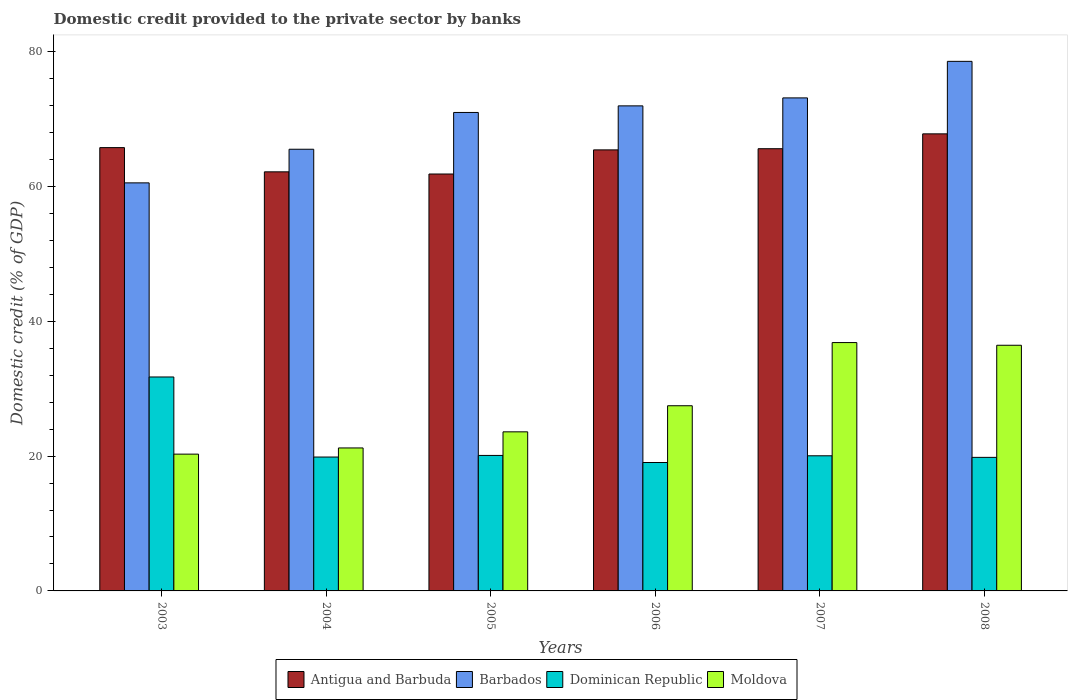How many different coloured bars are there?
Your response must be concise. 4. Are the number of bars per tick equal to the number of legend labels?
Provide a short and direct response. Yes. How many bars are there on the 4th tick from the left?
Keep it short and to the point. 4. In how many cases, is the number of bars for a given year not equal to the number of legend labels?
Give a very brief answer. 0. What is the domestic credit provided to the private sector by banks in Dominican Republic in 2007?
Your response must be concise. 20.05. Across all years, what is the maximum domestic credit provided to the private sector by banks in Antigua and Barbuda?
Offer a terse response. 67.81. Across all years, what is the minimum domestic credit provided to the private sector by banks in Dominican Republic?
Offer a terse response. 19.05. In which year was the domestic credit provided to the private sector by banks in Dominican Republic maximum?
Your answer should be compact. 2003. What is the total domestic credit provided to the private sector by banks in Barbados in the graph?
Provide a succinct answer. 420.73. What is the difference between the domestic credit provided to the private sector by banks in Barbados in 2004 and that in 2007?
Ensure brevity in your answer.  -7.62. What is the difference between the domestic credit provided to the private sector by banks in Dominican Republic in 2003 and the domestic credit provided to the private sector by banks in Antigua and Barbuda in 2004?
Your answer should be very brief. -30.43. What is the average domestic credit provided to the private sector by banks in Moldova per year?
Make the answer very short. 27.65. In the year 2005, what is the difference between the domestic credit provided to the private sector by banks in Barbados and domestic credit provided to the private sector by banks in Dominican Republic?
Offer a very short reply. 50.88. What is the ratio of the domestic credit provided to the private sector by banks in Dominican Republic in 2003 to that in 2004?
Keep it short and to the point. 1.6. Is the difference between the domestic credit provided to the private sector by banks in Barbados in 2004 and 2008 greater than the difference between the domestic credit provided to the private sector by banks in Dominican Republic in 2004 and 2008?
Provide a short and direct response. No. What is the difference between the highest and the second highest domestic credit provided to the private sector by banks in Dominican Republic?
Your response must be concise. 11.64. What is the difference between the highest and the lowest domestic credit provided to the private sector by banks in Antigua and Barbuda?
Offer a terse response. 5.96. In how many years, is the domestic credit provided to the private sector by banks in Moldova greater than the average domestic credit provided to the private sector by banks in Moldova taken over all years?
Ensure brevity in your answer.  2. Is the sum of the domestic credit provided to the private sector by banks in Moldova in 2004 and 2007 greater than the maximum domestic credit provided to the private sector by banks in Antigua and Barbuda across all years?
Offer a very short reply. No. Is it the case that in every year, the sum of the domestic credit provided to the private sector by banks in Antigua and Barbuda and domestic credit provided to the private sector by banks in Barbados is greater than the sum of domestic credit provided to the private sector by banks in Moldova and domestic credit provided to the private sector by banks in Dominican Republic?
Keep it short and to the point. Yes. What does the 4th bar from the left in 2008 represents?
Give a very brief answer. Moldova. What does the 1st bar from the right in 2003 represents?
Give a very brief answer. Moldova. How many bars are there?
Offer a terse response. 24. Are all the bars in the graph horizontal?
Provide a succinct answer. No. How many years are there in the graph?
Ensure brevity in your answer.  6. Are the values on the major ticks of Y-axis written in scientific E-notation?
Ensure brevity in your answer.  No. Does the graph contain any zero values?
Give a very brief answer. No. How are the legend labels stacked?
Keep it short and to the point. Horizontal. What is the title of the graph?
Ensure brevity in your answer.  Domestic credit provided to the private sector by banks. Does "Middle income" appear as one of the legend labels in the graph?
Offer a terse response. No. What is the label or title of the X-axis?
Offer a terse response. Years. What is the label or title of the Y-axis?
Your answer should be very brief. Domestic credit (% of GDP). What is the Domestic credit (% of GDP) in Antigua and Barbuda in 2003?
Ensure brevity in your answer.  65.77. What is the Domestic credit (% of GDP) in Barbados in 2003?
Your answer should be very brief. 60.54. What is the Domestic credit (% of GDP) in Dominican Republic in 2003?
Your answer should be very brief. 31.74. What is the Domestic credit (% of GDP) in Moldova in 2003?
Offer a terse response. 20.29. What is the Domestic credit (% of GDP) in Antigua and Barbuda in 2004?
Ensure brevity in your answer.  62.18. What is the Domestic credit (% of GDP) of Barbados in 2004?
Make the answer very short. 65.53. What is the Domestic credit (% of GDP) of Dominican Republic in 2004?
Provide a short and direct response. 19.86. What is the Domestic credit (% of GDP) in Moldova in 2004?
Provide a short and direct response. 21.21. What is the Domestic credit (% of GDP) of Antigua and Barbuda in 2005?
Your answer should be very brief. 61.85. What is the Domestic credit (% of GDP) in Barbados in 2005?
Ensure brevity in your answer.  70.98. What is the Domestic credit (% of GDP) in Dominican Republic in 2005?
Offer a very short reply. 20.1. What is the Domestic credit (% of GDP) in Moldova in 2005?
Your answer should be compact. 23.6. What is the Domestic credit (% of GDP) in Antigua and Barbuda in 2006?
Your response must be concise. 65.43. What is the Domestic credit (% of GDP) of Barbados in 2006?
Your response must be concise. 71.96. What is the Domestic credit (% of GDP) in Dominican Republic in 2006?
Keep it short and to the point. 19.05. What is the Domestic credit (% of GDP) of Moldova in 2006?
Keep it short and to the point. 27.47. What is the Domestic credit (% of GDP) in Antigua and Barbuda in 2007?
Your response must be concise. 65.61. What is the Domestic credit (% of GDP) of Barbados in 2007?
Offer a very short reply. 73.15. What is the Domestic credit (% of GDP) of Dominican Republic in 2007?
Your answer should be very brief. 20.05. What is the Domestic credit (% of GDP) of Moldova in 2007?
Your answer should be compact. 36.85. What is the Domestic credit (% of GDP) of Antigua and Barbuda in 2008?
Your answer should be compact. 67.81. What is the Domestic credit (% of GDP) in Barbados in 2008?
Give a very brief answer. 78.57. What is the Domestic credit (% of GDP) in Dominican Republic in 2008?
Your answer should be very brief. 19.81. What is the Domestic credit (% of GDP) of Moldova in 2008?
Provide a succinct answer. 36.45. Across all years, what is the maximum Domestic credit (% of GDP) of Antigua and Barbuda?
Provide a short and direct response. 67.81. Across all years, what is the maximum Domestic credit (% of GDP) in Barbados?
Keep it short and to the point. 78.57. Across all years, what is the maximum Domestic credit (% of GDP) of Dominican Republic?
Offer a very short reply. 31.74. Across all years, what is the maximum Domestic credit (% of GDP) in Moldova?
Ensure brevity in your answer.  36.85. Across all years, what is the minimum Domestic credit (% of GDP) of Antigua and Barbuda?
Provide a short and direct response. 61.85. Across all years, what is the minimum Domestic credit (% of GDP) in Barbados?
Your answer should be compact. 60.54. Across all years, what is the minimum Domestic credit (% of GDP) in Dominican Republic?
Provide a succinct answer. 19.05. Across all years, what is the minimum Domestic credit (% of GDP) of Moldova?
Keep it short and to the point. 20.29. What is the total Domestic credit (% of GDP) of Antigua and Barbuda in the graph?
Provide a succinct answer. 388.65. What is the total Domestic credit (% of GDP) of Barbados in the graph?
Offer a terse response. 420.73. What is the total Domestic credit (% of GDP) of Dominican Republic in the graph?
Your answer should be very brief. 130.62. What is the total Domestic credit (% of GDP) of Moldova in the graph?
Make the answer very short. 165.87. What is the difference between the Domestic credit (% of GDP) in Antigua and Barbuda in 2003 and that in 2004?
Offer a very short reply. 3.59. What is the difference between the Domestic credit (% of GDP) in Barbados in 2003 and that in 2004?
Keep it short and to the point. -4.99. What is the difference between the Domestic credit (% of GDP) in Dominican Republic in 2003 and that in 2004?
Keep it short and to the point. 11.88. What is the difference between the Domestic credit (% of GDP) of Moldova in 2003 and that in 2004?
Ensure brevity in your answer.  -0.92. What is the difference between the Domestic credit (% of GDP) of Antigua and Barbuda in 2003 and that in 2005?
Your answer should be very brief. 3.91. What is the difference between the Domestic credit (% of GDP) in Barbados in 2003 and that in 2005?
Keep it short and to the point. -10.44. What is the difference between the Domestic credit (% of GDP) in Dominican Republic in 2003 and that in 2005?
Offer a terse response. 11.64. What is the difference between the Domestic credit (% of GDP) of Moldova in 2003 and that in 2005?
Your answer should be compact. -3.31. What is the difference between the Domestic credit (% of GDP) of Antigua and Barbuda in 2003 and that in 2006?
Offer a very short reply. 0.33. What is the difference between the Domestic credit (% of GDP) in Barbados in 2003 and that in 2006?
Ensure brevity in your answer.  -11.42. What is the difference between the Domestic credit (% of GDP) in Dominican Republic in 2003 and that in 2006?
Offer a terse response. 12.69. What is the difference between the Domestic credit (% of GDP) in Moldova in 2003 and that in 2006?
Keep it short and to the point. -7.18. What is the difference between the Domestic credit (% of GDP) in Antigua and Barbuda in 2003 and that in 2007?
Make the answer very short. 0.16. What is the difference between the Domestic credit (% of GDP) of Barbados in 2003 and that in 2007?
Your answer should be very brief. -12.61. What is the difference between the Domestic credit (% of GDP) in Dominican Republic in 2003 and that in 2007?
Make the answer very short. 11.69. What is the difference between the Domestic credit (% of GDP) of Moldova in 2003 and that in 2007?
Ensure brevity in your answer.  -16.55. What is the difference between the Domestic credit (% of GDP) of Antigua and Barbuda in 2003 and that in 2008?
Offer a terse response. -2.04. What is the difference between the Domestic credit (% of GDP) in Barbados in 2003 and that in 2008?
Provide a short and direct response. -18.03. What is the difference between the Domestic credit (% of GDP) of Dominican Republic in 2003 and that in 2008?
Your answer should be very brief. 11.93. What is the difference between the Domestic credit (% of GDP) of Moldova in 2003 and that in 2008?
Your answer should be very brief. -16.15. What is the difference between the Domestic credit (% of GDP) of Antigua and Barbuda in 2004 and that in 2005?
Provide a short and direct response. 0.32. What is the difference between the Domestic credit (% of GDP) in Barbados in 2004 and that in 2005?
Provide a short and direct response. -5.46. What is the difference between the Domestic credit (% of GDP) of Dominican Republic in 2004 and that in 2005?
Your answer should be compact. -0.24. What is the difference between the Domestic credit (% of GDP) in Moldova in 2004 and that in 2005?
Keep it short and to the point. -2.39. What is the difference between the Domestic credit (% of GDP) in Antigua and Barbuda in 2004 and that in 2006?
Ensure brevity in your answer.  -3.26. What is the difference between the Domestic credit (% of GDP) in Barbados in 2004 and that in 2006?
Provide a succinct answer. -6.44. What is the difference between the Domestic credit (% of GDP) in Dominican Republic in 2004 and that in 2006?
Your answer should be very brief. 0.81. What is the difference between the Domestic credit (% of GDP) in Moldova in 2004 and that in 2006?
Ensure brevity in your answer.  -6.26. What is the difference between the Domestic credit (% of GDP) in Antigua and Barbuda in 2004 and that in 2007?
Your response must be concise. -3.43. What is the difference between the Domestic credit (% of GDP) in Barbados in 2004 and that in 2007?
Your answer should be very brief. -7.62. What is the difference between the Domestic credit (% of GDP) of Dominican Republic in 2004 and that in 2007?
Provide a succinct answer. -0.19. What is the difference between the Domestic credit (% of GDP) in Moldova in 2004 and that in 2007?
Keep it short and to the point. -15.63. What is the difference between the Domestic credit (% of GDP) of Antigua and Barbuda in 2004 and that in 2008?
Provide a short and direct response. -5.63. What is the difference between the Domestic credit (% of GDP) of Barbados in 2004 and that in 2008?
Your response must be concise. -13.04. What is the difference between the Domestic credit (% of GDP) in Dominican Republic in 2004 and that in 2008?
Your response must be concise. 0.05. What is the difference between the Domestic credit (% of GDP) of Moldova in 2004 and that in 2008?
Your response must be concise. -15.23. What is the difference between the Domestic credit (% of GDP) of Antigua and Barbuda in 2005 and that in 2006?
Offer a terse response. -3.58. What is the difference between the Domestic credit (% of GDP) in Barbados in 2005 and that in 2006?
Ensure brevity in your answer.  -0.98. What is the difference between the Domestic credit (% of GDP) in Dominican Republic in 2005 and that in 2006?
Offer a terse response. 1.05. What is the difference between the Domestic credit (% of GDP) in Moldova in 2005 and that in 2006?
Your response must be concise. -3.87. What is the difference between the Domestic credit (% of GDP) of Antigua and Barbuda in 2005 and that in 2007?
Offer a very short reply. -3.75. What is the difference between the Domestic credit (% of GDP) in Barbados in 2005 and that in 2007?
Give a very brief answer. -2.16. What is the difference between the Domestic credit (% of GDP) of Dominican Republic in 2005 and that in 2007?
Provide a short and direct response. 0.05. What is the difference between the Domestic credit (% of GDP) of Moldova in 2005 and that in 2007?
Make the answer very short. -13.24. What is the difference between the Domestic credit (% of GDP) of Antigua and Barbuda in 2005 and that in 2008?
Your answer should be compact. -5.96. What is the difference between the Domestic credit (% of GDP) in Barbados in 2005 and that in 2008?
Ensure brevity in your answer.  -7.58. What is the difference between the Domestic credit (% of GDP) of Dominican Republic in 2005 and that in 2008?
Keep it short and to the point. 0.29. What is the difference between the Domestic credit (% of GDP) of Moldova in 2005 and that in 2008?
Ensure brevity in your answer.  -12.85. What is the difference between the Domestic credit (% of GDP) of Antigua and Barbuda in 2006 and that in 2007?
Your answer should be very brief. -0.17. What is the difference between the Domestic credit (% of GDP) of Barbados in 2006 and that in 2007?
Ensure brevity in your answer.  -1.18. What is the difference between the Domestic credit (% of GDP) in Dominican Republic in 2006 and that in 2007?
Offer a very short reply. -1. What is the difference between the Domestic credit (% of GDP) in Moldova in 2006 and that in 2007?
Your answer should be very brief. -9.37. What is the difference between the Domestic credit (% of GDP) in Antigua and Barbuda in 2006 and that in 2008?
Your response must be concise. -2.38. What is the difference between the Domestic credit (% of GDP) of Barbados in 2006 and that in 2008?
Ensure brevity in your answer.  -6.6. What is the difference between the Domestic credit (% of GDP) of Dominican Republic in 2006 and that in 2008?
Offer a terse response. -0.76. What is the difference between the Domestic credit (% of GDP) in Moldova in 2006 and that in 2008?
Your response must be concise. -8.97. What is the difference between the Domestic credit (% of GDP) of Antigua and Barbuda in 2007 and that in 2008?
Your response must be concise. -2.2. What is the difference between the Domestic credit (% of GDP) in Barbados in 2007 and that in 2008?
Make the answer very short. -5.42. What is the difference between the Domestic credit (% of GDP) of Dominican Republic in 2007 and that in 2008?
Your answer should be compact. 0.23. What is the difference between the Domestic credit (% of GDP) of Moldova in 2007 and that in 2008?
Make the answer very short. 0.4. What is the difference between the Domestic credit (% of GDP) in Antigua and Barbuda in 2003 and the Domestic credit (% of GDP) in Barbados in 2004?
Your answer should be compact. 0.24. What is the difference between the Domestic credit (% of GDP) of Antigua and Barbuda in 2003 and the Domestic credit (% of GDP) of Dominican Republic in 2004?
Your answer should be very brief. 45.91. What is the difference between the Domestic credit (% of GDP) in Antigua and Barbuda in 2003 and the Domestic credit (% of GDP) in Moldova in 2004?
Give a very brief answer. 44.56. What is the difference between the Domestic credit (% of GDP) in Barbados in 2003 and the Domestic credit (% of GDP) in Dominican Republic in 2004?
Your answer should be very brief. 40.68. What is the difference between the Domestic credit (% of GDP) in Barbados in 2003 and the Domestic credit (% of GDP) in Moldova in 2004?
Provide a succinct answer. 39.33. What is the difference between the Domestic credit (% of GDP) of Dominican Republic in 2003 and the Domestic credit (% of GDP) of Moldova in 2004?
Your answer should be very brief. 10.53. What is the difference between the Domestic credit (% of GDP) of Antigua and Barbuda in 2003 and the Domestic credit (% of GDP) of Barbados in 2005?
Your answer should be compact. -5.22. What is the difference between the Domestic credit (% of GDP) in Antigua and Barbuda in 2003 and the Domestic credit (% of GDP) in Dominican Republic in 2005?
Offer a very short reply. 45.67. What is the difference between the Domestic credit (% of GDP) of Antigua and Barbuda in 2003 and the Domestic credit (% of GDP) of Moldova in 2005?
Your answer should be compact. 42.17. What is the difference between the Domestic credit (% of GDP) in Barbados in 2003 and the Domestic credit (% of GDP) in Dominican Republic in 2005?
Give a very brief answer. 40.44. What is the difference between the Domestic credit (% of GDP) of Barbados in 2003 and the Domestic credit (% of GDP) of Moldova in 2005?
Provide a short and direct response. 36.94. What is the difference between the Domestic credit (% of GDP) in Dominican Republic in 2003 and the Domestic credit (% of GDP) in Moldova in 2005?
Give a very brief answer. 8.14. What is the difference between the Domestic credit (% of GDP) of Antigua and Barbuda in 2003 and the Domestic credit (% of GDP) of Barbados in 2006?
Keep it short and to the point. -6.2. What is the difference between the Domestic credit (% of GDP) of Antigua and Barbuda in 2003 and the Domestic credit (% of GDP) of Dominican Republic in 2006?
Provide a short and direct response. 46.72. What is the difference between the Domestic credit (% of GDP) of Antigua and Barbuda in 2003 and the Domestic credit (% of GDP) of Moldova in 2006?
Keep it short and to the point. 38.3. What is the difference between the Domestic credit (% of GDP) of Barbados in 2003 and the Domestic credit (% of GDP) of Dominican Republic in 2006?
Offer a very short reply. 41.49. What is the difference between the Domestic credit (% of GDP) in Barbados in 2003 and the Domestic credit (% of GDP) in Moldova in 2006?
Offer a very short reply. 33.07. What is the difference between the Domestic credit (% of GDP) in Dominican Republic in 2003 and the Domestic credit (% of GDP) in Moldova in 2006?
Provide a succinct answer. 4.27. What is the difference between the Domestic credit (% of GDP) in Antigua and Barbuda in 2003 and the Domestic credit (% of GDP) in Barbados in 2007?
Give a very brief answer. -7.38. What is the difference between the Domestic credit (% of GDP) in Antigua and Barbuda in 2003 and the Domestic credit (% of GDP) in Dominican Republic in 2007?
Give a very brief answer. 45.72. What is the difference between the Domestic credit (% of GDP) of Antigua and Barbuda in 2003 and the Domestic credit (% of GDP) of Moldova in 2007?
Offer a terse response. 28.92. What is the difference between the Domestic credit (% of GDP) of Barbados in 2003 and the Domestic credit (% of GDP) of Dominican Republic in 2007?
Provide a short and direct response. 40.49. What is the difference between the Domestic credit (% of GDP) in Barbados in 2003 and the Domestic credit (% of GDP) in Moldova in 2007?
Offer a terse response. 23.69. What is the difference between the Domestic credit (% of GDP) of Dominican Republic in 2003 and the Domestic credit (% of GDP) of Moldova in 2007?
Offer a terse response. -5.1. What is the difference between the Domestic credit (% of GDP) in Antigua and Barbuda in 2003 and the Domestic credit (% of GDP) in Barbados in 2008?
Make the answer very short. -12.8. What is the difference between the Domestic credit (% of GDP) in Antigua and Barbuda in 2003 and the Domestic credit (% of GDP) in Dominican Republic in 2008?
Keep it short and to the point. 45.95. What is the difference between the Domestic credit (% of GDP) in Antigua and Barbuda in 2003 and the Domestic credit (% of GDP) in Moldova in 2008?
Provide a short and direct response. 29.32. What is the difference between the Domestic credit (% of GDP) in Barbados in 2003 and the Domestic credit (% of GDP) in Dominican Republic in 2008?
Provide a succinct answer. 40.72. What is the difference between the Domestic credit (% of GDP) in Barbados in 2003 and the Domestic credit (% of GDP) in Moldova in 2008?
Your answer should be compact. 24.09. What is the difference between the Domestic credit (% of GDP) in Dominican Republic in 2003 and the Domestic credit (% of GDP) in Moldova in 2008?
Ensure brevity in your answer.  -4.71. What is the difference between the Domestic credit (% of GDP) in Antigua and Barbuda in 2004 and the Domestic credit (% of GDP) in Barbados in 2005?
Ensure brevity in your answer.  -8.81. What is the difference between the Domestic credit (% of GDP) in Antigua and Barbuda in 2004 and the Domestic credit (% of GDP) in Dominican Republic in 2005?
Your response must be concise. 42.07. What is the difference between the Domestic credit (% of GDP) of Antigua and Barbuda in 2004 and the Domestic credit (% of GDP) of Moldova in 2005?
Provide a succinct answer. 38.57. What is the difference between the Domestic credit (% of GDP) in Barbados in 2004 and the Domestic credit (% of GDP) in Dominican Republic in 2005?
Give a very brief answer. 45.43. What is the difference between the Domestic credit (% of GDP) of Barbados in 2004 and the Domestic credit (% of GDP) of Moldova in 2005?
Provide a short and direct response. 41.93. What is the difference between the Domestic credit (% of GDP) in Dominican Republic in 2004 and the Domestic credit (% of GDP) in Moldova in 2005?
Provide a succinct answer. -3.74. What is the difference between the Domestic credit (% of GDP) of Antigua and Barbuda in 2004 and the Domestic credit (% of GDP) of Barbados in 2006?
Make the answer very short. -9.79. What is the difference between the Domestic credit (% of GDP) in Antigua and Barbuda in 2004 and the Domestic credit (% of GDP) in Dominican Republic in 2006?
Give a very brief answer. 43.12. What is the difference between the Domestic credit (% of GDP) of Antigua and Barbuda in 2004 and the Domestic credit (% of GDP) of Moldova in 2006?
Ensure brevity in your answer.  34.7. What is the difference between the Domestic credit (% of GDP) in Barbados in 2004 and the Domestic credit (% of GDP) in Dominican Republic in 2006?
Offer a very short reply. 46.48. What is the difference between the Domestic credit (% of GDP) in Barbados in 2004 and the Domestic credit (% of GDP) in Moldova in 2006?
Provide a succinct answer. 38.05. What is the difference between the Domestic credit (% of GDP) in Dominican Republic in 2004 and the Domestic credit (% of GDP) in Moldova in 2006?
Your response must be concise. -7.61. What is the difference between the Domestic credit (% of GDP) in Antigua and Barbuda in 2004 and the Domestic credit (% of GDP) in Barbados in 2007?
Offer a terse response. -10.97. What is the difference between the Domestic credit (% of GDP) in Antigua and Barbuda in 2004 and the Domestic credit (% of GDP) in Dominican Republic in 2007?
Give a very brief answer. 42.13. What is the difference between the Domestic credit (% of GDP) in Antigua and Barbuda in 2004 and the Domestic credit (% of GDP) in Moldova in 2007?
Your response must be concise. 25.33. What is the difference between the Domestic credit (% of GDP) in Barbados in 2004 and the Domestic credit (% of GDP) in Dominican Republic in 2007?
Your response must be concise. 45.48. What is the difference between the Domestic credit (% of GDP) of Barbados in 2004 and the Domestic credit (% of GDP) of Moldova in 2007?
Offer a very short reply. 28.68. What is the difference between the Domestic credit (% of GDP) in Dominican Republic in 2004 and the Domestic credit (% of GDP) in Moldova in 2007?
Ensure brevity in your answer.  -16.98. What is the difference between the Domestic credit (% of GDP) in Antigua and Barbuda in 2004 and the Domestic credit (% of GDP) in Barbados in 2008?
Give a very brief answer. -16.39. What is the difference between the Domestic credit (% of GDP) in Antigua and Barbuda in 2004 and the Domestic credit (% of GDP) in Dominican Republic in 2008?
Your response must be concise. 42.36. What is the difference between the Domestic credit (% of GDP) of Antigua and Barbuda in 2004 and the Domestic credit (% of GDP) of Moldova in 2008?
Offer a terse response. 25.73. What is the difference between the Domestic credit (% of GDP) in Barbados in 2004 and the Domestic credit (% of GDP) in Dominican Republic in 2008?
Offer a terse response. 45.71. What is the difference between the Domestic credit (% of GDP) in Barbados in 2004 and the Domestic credit (% of GDP) in Moldova in 2008?
Your response must be concise. 29.08. What is the difference between the Domestic credit (% of GDP) of Dominican Republic in 2004 and the Domestic credit (% of GDP) of Moldova in 2008?
Offer a very short reply. -16.58. What is the difference between the Domestic credit (% of GDP) in Antigua and Barbuda in 2005 and the Domestic credit (% of GDP) in Barbados in 2006?
Keep it short and to the point. -10.11. What is the difference between the Domestic credit (% of GDP) of Antigua and Barbuda in 2005 and the Domestic credit (% of GDP) of Dominican Republic in 2006?
Give a very brief answer. 42.8. What is the difference between the Domestic credit (% of GDP) in Antigua and Barbuda in 2005 and the Domestic credit (% of GDP) in Moldova in 2006?
Your answer should be very brief. 34.38. What is the difference between the Domestic credit (% of GDP) in Barbados in 2005 and the Domestic credit (% of GDP) in Dominican Republic in 2006?
Keep it short and to the point. 51.93. What is the difference between the Domestic credit (% of GDP) of Barbados in 2005 and the Domestic credit (% of GDP) of Moldova in 2006?
Offer a very short reply. 43.51. What is the difference between the Domestic credit (% of GDP) of Dominican Republic in 2005 and the Domestic credit (% of GDP) of Moldova in 2006?
Make the answer very short. -7.37. What is the difference between the Domestic credit (% of GDP) of Antigua and Barbuda in 2005 and the Domestic credit (% of GDP) of Barbados in 2007?
Provide a short and direct response. -11.29. What is the difference between the Domestic credit (% of GDP) of Antigua and Barbuda in 2005 and the Domestic credit (% of GDP) of Dominican Republic in 2007?
Provide a succinct answer. 41.8. What is the difference between the Domestic credit (% of GDP) of Antigua and Barbuda in 2005 and the Domestic credit (% of GDP) of Moldova in 2007?
Your answer should be compact. 25.01. What is the difference between the Domestic credit (% of GDP) of Barbados in 2005 and the Domestic credit (% of GDP) of Dominican Republic in 2007?
Your answer should be compact. 50.94. What is the difference between the Domestic credit (% of GDP) of Barbados in 2005 and the Domestic credit (% of GDP) of Moldova in 2007?
Keep it short and to the point. 34.14. What is the difference between the Domestic credit (% of GDP) of Dominican Republic in 2005 and the Domestic credit (% of GDP) of Moldova in 2007?
Offer a terse response. -16.74. What is the difference between the Domestic credit (% of GDP) in Antigua and Barbuda in 2005 and the Domestic credit (% of GDP) in Barbados in 2008?
Ensure brevity in your answer.  -16.71. What is the difference between the Domestic credit (% of GDP) of Antigua and Barbuda in 2005 and the Domestic credit (% of GDP) of Dominican Republic in 2008?
Provide a succinct answer. 42.04. What is the difference between the Domestic credit (% of GDP) of Antigua and Barbuda in 2005 and the Domestic credit (% of GDP) of Moldova in 2008?
Your answer should be very brief. 25.41. What is the difference between the Domestic credit (% of GDP) in Barbados in 2005 and the Domestic credit (% of GDP) in Dominican Republic in 2008?
Offer a very short reply. 51.17. What is the difference between the Domestic credit (% of GDP) of Barbados in 2005 and the Domestic credit (% of GDP) of Moldova in 2008?
Offer a very short reply. 34.54. What is the difference between the Domestic credit (% of GDP) in Dominican Republic in 2005 and the Domestic credit (% of GDP) in Moldova in 2008?
Give a very brief answer. -16.34. What is the difference between the Domestic credit (% of GDP) in Antigua and Barbuda in 2006 and the Domestic credit (% of GDP) in Barbados in 2007?
Your response must be concise. -7.71. What is the difference between the Domestic credit (% of GDP) of Antigua and Barbuda in 2006 and the Domestic credit (% of GDP) of Dominican Republic in 2007?
Ensure brevity in your answer.  45.39. What is the difference between the Domestic credit (% of GDP) of Antigua and Barbuda in 2006 and the Domestic credit (% of GDP) of Moldova in 2007?
Ensure brevity in your answer.  28.59. What is the difference between the Domestic credit (% of GDP) in Barbados in 2006 and the Domestic credit (% of GDP) in Dominican Republic in 2007?
Offer a terse response. 51.91. What is the difference between the Domestic credit (% of GDP) in Barbados in 2006 and the Domestic credit (% of GDP) in Moldova in 2007?
Your answer should be compact. 35.12. What is the difference between the Domestic credit (% of GDP) in Dominican Republic in 2006 and the Domestic credit (% of GDP) in Moldova in 2007?
Your response must be concise. -17.79. What is the difference between the Domestic credit (% of GDP) of Antigua and Barbuda in 2006 and the Domestic credit (% of GDP) of Barbados in 2008?
Your answer should be very brief. -13.13. What is the difference between the Domestic credit (% of GDP) in Antigua and Barbuda in 2006 and the Domestic credit (% of GDP) in Dominican Republic in 2008?
Give a very brief answer. 45.62. What is the difference between the Domestic credit (% of GDP) in Antigua and Barbuda in 2006 and the Domestic credit (% of GDP) in Moldova in 2008?
Offer a terse response. 28.99. What is the difference between the Domestic credit (% of GDP) in Barbados in 2006 and the Domestic credit (% of GDP) in Dominican Republic in 2008?
Make the answer very short. 52.15. What is the difference between the Domestic credit (% of GDP) in Barbados in 2006 and the Domestic credit (% of GDP) in Moldova in 2008?
Make the answer very short. 35.52. What is the difference between the Domestic credit (% of GDP) in Dominican Republic in 2006 and the Domestic credit (% of GDP) in Moldova in 2008?
Offer a very short reply. -17.39. What is the difference between the Domestic credit (% of GDP) of Antigua and Barbuda in 2007 and the Domestic credit (% of GDP) of Barbados in 2008?
Keep it short and to the point. -12.96. What is the difference between the Domestic credit (% of GDP) in Antigua and Barbuda in 2007 and the Domestic credit (% of GDP) in Dominican Republic in 2008?
Offer a terse response. 45.79. What is the difference between the Domestic credit (% of GDP) of Antigua and Barbuda in 2007 and the Domestic credit (% of GDP) of Moldova in 2008?
Provide a succinct answer. 29.16. What is the difference between the Domestic credit (% of GDP) of Barbados in 2007 and the Domestic credit (% of GDP) of Dominican Republic in 2008?
Make the answer very short. 53.33. What is the difference between the Domestic credit (% of GDP) in Barbados in 2007 and the Domestic credit (% of GDP) in Moldova in 2008?
Ensure brevity in your answer.  36.7. What is the difference between the Domestic credit (% of GDP) in Dominican Republic in 2007 and the Domestic credit (% of GDP) in Moldova in 2008?
Offer a terse response. -16.4. What is the average Domestic credit (% of GDP) of Antigua and Barbuda per year?
Give a very brief answer. 64.77. What is the average Domestic credit (% of GDP) of Barbados per year?
Your response must be concise. 70.12. What is the average Domestic credit (% of GDP) in Dominican Republic per year?
Your answer should be very brief. 21.77. What is the average Domestic credit (% of GDP) of Moldova per year?
Your answer should be very brief. 27.65. In the year 2003, what is the difference between the Domestic credit (% of GDP) of Antigua and Barbuda and Domestic credit (% of GDP) of Barbados?
Provide a short and direct response. 5.23. In the year 2003, what is the difference between the Domestic credit (% of GDP) of Antigua and Barbuda and Domestic credit (% of GDP) of Dominican Republic?
Provide a succinct answer. 34.03. In the year 2003, what is the difference between the Domestic credit (% of GDP) of Antigua and Barbuda and Domestic credit (% of GDP) of Moldova?
Give a very brief answer. 45.47. In the year 2003, what is the difference between the Domestic credit (% of GDP) of Barbados and Domestic credit (% of GDP) of Dominican Republic?
Give a very brief answer. 28.8. In the year 2003, what is the difference between the Domestic credit (% of GDP) of Barbados and Domestic credit (% of GDP) of Moldova?
Your answer should be very brief. 40.24. In the year 2003, what is the difference between the Domestic credit (% of GDP) of Dominican Republic and Domestic credit (% of GDP) of Moldova?
Give a very brief answer. 11.45. In the year 2004, what is the difference between the Domestic credit (% of GDP) of Antigua and Barbuda and Domestic credit (% of GDP) of Barbados?
Your response must be concise. -3.35. In the year 2004, what is the difference between the Domestic credit (% of GDP) in Antigua and Barbuda and Domestic credit (% of GDP) in Dominican Republic?
Make the answer very short. 42.31. In the year 2004, what is the difference between the Domestic credit (% of GDP) in Antigua and Barbuda and Domestic credit (% of GDP) in Moldova?
Make the answer very short. 40.96. In the year 2004, what is the difference between the Domestic credit (% of GDP) of Barbados and Domestic credit (% of GDP) of Dominican Republic?
Your answer should be very brief. 45.67. In the year 2004, what is the difference between the Domestic credit (% of GDP) in Barbados and Domestic credit (% of GDP) in Moldova?
Keep it short and to the point. 44.31. In the year 2004, what is the difference between the Domestic credit (% of GDP) in Dominican Republic and Domestic credit (% of GDP) in Moldova?
Keep it short and to the point. -1.35. In the year 2005, what is the difference between the Domestic credit (% of GDP) in Antigua and Barbuda and Domestic credit (% of GDP) in Barbados?
Provide a short and direct response. -9.13. In the year 2005, what is the difference between the Domestic credit (% of GDP) in Antigua and Barbuda and Domestic credit (% of GDP) in Dominican Republic?
Your answer should be compact. 41.75. In the year 2005, what is the difference between the Domestic credit (% of GDP) of Antigua and Barbuda and Domestic credit (% of GDP) of Moldova?
Your answer should be compact. 38.25. In the year 2005, what is the difference between the Domestic credit (% of GDP) of Barbados and Domestic credit (% of GDP) of Dominican Republic?
Provide a succinct answer. 50.88. In the year 2005, what is the difference between the Domestic credit (% of GDP) of Barbados and Domestic credit (% of GDP) of Moldova?
Your answer should be very brief. 47.38. In the year 2005, what is the difference between the Domestic credit (% of GDP) in Dominican Republic and Domestic credit (% of GDP) in Moldova?
Your answer should be compact. -3.5. In the year 2006, what is the difference between the Domestic credit (% of GDP) in Antigua and Barbuda and Domestic credit (% of GDP) in Barbados?
Your response must be concise. -6.53. In the year 2006, what is the difference between the Domestic credit (% of GDP) in Antigua and Barbuda and Domestic credit (% of GDP) in Dominican Republic?
Give a very brief answer. 46.38. In the year 2006, what is the difference between the Domestic credit (% of GDP) of Antigua and Barbuda and Domestic credit (% of GDP) of Moldova?
Your answer should be very brief. 37.96. In the year 2006, what is the difference between the Domestic credit (% of GDP) in Barbados and Domestic credit (% of GDP) in Dominican Republic?
Provide a short and direct response. 52.91. In the year 2006, what is the difference between the Domestic credit (% of GDP) of Barbados and Domestic credit (% of GDP) of Moldova?
Your answer should be compact. 44.49. In the year 2006, what is the difference between the Domestic credit (% of GDP) in Dominican Republic and Domestic credit (% of GDP) in Moldova?
Your response must be concise. -8.42. In the year 2007, what is the difference between the Domestic credit (% of GDP) in Antigua and Barbuda and Domestic credit (% of GDP) in Barbados?
Keep it short and to the point. -7.54. In the year 2007, what is the difference between the Domestic credit (% of GDP) in Antigua and Barbuda and Domestic credit (% of GDP) in Dominican Republic?
Keep it short and to the point. 45.56. In the year 2007, what is the difference between the Domestic credit (% of GDP) in Antigua and Barbuda and Domestic credit (% of GDP) in Moldova?
Keep it short and to the point. 28.76. In the year 2007, what is the difference between the Domestic credit (% of GDP) of Barbados and Domestic credit (% of GDP) of Dominican Republic?
Your answer should be very brief. 53.1. In the year 2007, what is the difference between the Domestic credit (% of GDP) in Barbados and Domestic credit (% of GDP) in Moldova?
Offer a very short reply. 36.3. In the year 2007, what is the difference between the Domestic credit (% of GDP) in Dominican Republic and Domestic credit (% of GDP) in Moldova?
Offer a terse response. -16.8. In the year 2008, what is the difference between the Domestic credit (% of GDP) of Antigua and Barbuda and Domestic credit (% of GDP) of Barbados?
Your answer should be very brief. -10.76. In the year 2008, what is the difference between the Domestic credit (% of GDP) in Antigua and Barbuda and Domestic credit (% of GDP) in Dominican Republic?
Provide a short and direct response. 48. In the year 2008, what is the difference between the Domestic credit (% of GDP) of Antigua and Barbuda and Domestic credit (% of GDP) of Moldova?
Offer a terse response. 31.36. In the year 2008, what is the difference between the Domestic credit (% of GDP) in Barbados and Domestic credit (% of GDP) in Dominican Republic?
Make the answer very short. 58.75. In the year 2008, what is the difference between the Domestic credit (% of GDP) in Barbados and Domestic credit (% of GDP) in Moldova?
Provide a succinct answer. 42.12. In the year 2008, what is the difference between the Domestic credit (% of GDP) of Dominican Republic and Domestic credit (% of GDP) of Moldova?
Make the answer very short. -16.63. What is the ratio of the Domestic credit (% of GDP) of Antigua and Barbuda in 2003 to that in 2004?
Provide a succinct answer. 1.06. What is the ratio of the Domestic credit (% of GDP) of Barbados in 2003 to that in 2004?
Keep it short and to the point. 0.92. What is the ratio of the Domestic credit (% of GDP) in Dominican Republic in 2003 to that in 2004?
Offer a terse response. 1.6. What is the ratio of the Domestic credit (% of GDP) in Moldova in 2003 to that in 2004?
Your answer should be compact. 0.96. What is the ratio of the Domestic credit (% of GDP) in Antigua and Barbuda in 2003 to that in 2005?
Give a very brief answer. 1.06. What is the ratio of the Domestic credit (% of GDP) of Barbados in 2003 to that in 2005?
Offer a terse response. 0.85. What is the ratio of the Domestic credit (% of GDP) in Dominican Republic in 2003 to that in 2005?
Provide a succinct answer. 1.58. What is the ratio of the Domestic credit (% of GDP) in Moldova in 2003 to that in 2005?
Ensure brevity in your answer.  0.86. What is the ratio of the Domestic credit (% of GDP) in Antigua and Barbuda in 2003 to that in 2006?
Your response must be concise. 1.01. What is the ratio of the Domestic credit (% of GDP) in Barbados in 2003 to that in 2006?
Your answer should be very brief. 0.84. What is the ratio of the Domestic credit (% of GDP) of Dominican Republic in 2003 to that in 2006?
Your answer should be very brief. 1.67. What is the ratio of the Domestic credit (% of GDP) of Moldova in 2003 to that in 2006?
Make the answer very short. 0.74. What is the ratio of the Domestic credit (% of GDP) in Barbados in 2003 to that in 2007?
Your response must be concise. 0.83. What is the ratio of the Domestic credit (% of GDP) of Dominican Republic in 2003 to that in 2007?
Your response must be concise. 1.58. What is the ratio of the Domestic credit (% of GDP) of Moldova in 2003 to that in 2007?
Offer a very short reply. 0.55. What is the ratio of the Domestic credit (% of GDP) in Antigua and Barbuda in 2003 to that in 2008?
Offer a terse response. 0.97. What is the ratio of the Domestic credit (% of GDP) in Barbados in 2003 to that in 2008?
Your answer should be very brief. 0.77. What is the ratio of the Domestic credit (% of GDP) in Dominican Republic in 2003 to that in 2008?
Provide a succinct answer. 1.6. What is the ratio of the Domestic credit (% of GDP) in Moldova in 2003 to that in 2008?
Give a very brief answer. 0.56. What is the ratio of the Domestic credit (% of GDP) in Antigua and Barbuda in 2004 to that in 2005?
Your answer should be very brief. 1.01. What is the ratio of the Domestic credit (% of GDP) in Barbados in 2004 to that in 2005?
Provide a succinct answer. 0.92. What is the ratio of the Domestic credit (% of GDP) in Moldova in 2004 to that in 2005?
Ensure brevity in your answer.  0.9. What is the ratio of the Domestic credit (% of GDP) in Antigua and Barbuda in 2004 to that in 2006?
Provide a succinct answer. 0.95. What is the ratio of the Domestic credit (% of GDP) in Barbados in 2004 to that in 2006?
Make the answer very short. 0.91. What is the ratio of the Domestic credit (% of GDP) of Dominican Republic in 2004 to that in 2006?
Keep it short and to the point. 1.04. What is the ratio of the Domestic credit (% of GDP) in Moldova in 2004 to that in 2006?
Your answer should be compact. 0.77. What is the ratio of the Domestic credit (% of GDP) in Antigua and Barbuda in 2004 to that in 2007?
Your answer should be compact. 0.95. What is the ratio of the Domestic credit (% of GDP) of Barbados in 2004 to that in 2007?
Your answer should be compact. 0.9. What is the ratio of the Domestic credit (% of GDP) in Dominican Republic in 2004 to that in 2007?
Your answer should be very brief. 0.99. What is the ratio of the Domestic credit (% of GDP) in Moldova in 2004 to that in 2007?
Your answer should be compact. 0.58. What is the ratio of the Domestic credit (% of GDP) of Antigua and Barbuda in 2004 to that in 2008?
Keep it short and to the point. 0.92. What is the ratio of the Domestic credit (% of GDP) of Barbados in 2004 to that in 2008?
Provide a short and direct response. 0.83. What is the ratio of the Domestic credit (% of GDP) of Moldova in 2004 to that in 2008?
Keep it short and to the point. 0.58. What is the ratio of the Domestic credit (% of GDP) in Antigua and Barbuda in 2005 to that in 2006?
Ensure brevity in your answer.  0.95. What is the ratio of the Domestic credit (% of GDP) of Barbados in 2005 to that in 2006?
Your response must be concise. 0.99. What is the ratio of the Domestic credit (% of GDP) of Dominican Republic in 2005 to that in 2006?
Provide a succinct answer. 1.06. What is the ratio of the Domestic credit (% of GDP) in Moldova in 2005 to that in 2006?
Ensure brevity in your answer.  0.86. What is the ratio of the Domestic credit (% of GDP) in Antigua and Barbuda in 2005 to that in 2007?
Offer a terse response. 0.94. What is the ratio of the Domestic credit (% of GDP) of Barbados in 2005 to that in 2007?
Your response must be concise. 0.97. What is the ratio of the Domestic credit (% of GDP) of Moldova in 2005 to that in 2007?
Ensure brevity in your answer.  0.64. What is the ratio of the Domestic credit (% of GDP) in Antigua and Barbuda in 2005 to that in 2008?
Provide a short and direct response. 0.91. What is the ratio of the Domestic credit (% of GDP) in Barbados in 2005 to that in 2008?
Keep it short and to the point. 0.9. What is the ratio of the Domestic credit (% of GDP) in Dominican Republic in 2005 to that in 2008?
Your response must be concise. 1.01. What is the ratio of the Domestic credit (% of GDP) of Moldova in 2005 to that in 2008?
Ensure brevity in your answer.  0.65. What is the ratio of the Domestic credit (% of GDP) of Barbados in 2006 to that in 2007?
Keep it short and to the point. 0.98. What is the ratio of the Domestic credit (% of GDP) in Dominican Republic in 2006 to that in 2007?
Your answer should be very brief. 0.95. What is the ratio of the Domestic credit (% of GDP) of Moldova in 2006 to that in 2007?
Provide a succinct answer. 0.75. What is the ratio of the Domestic credit (% of GDP) in Antigua and Barbuda in 2006 to that in 2008?
Your response must be concise. 0.96. What is the ratio of the Domestic credit (% of GDP) in Barbados in 2006 to that in 2008?
Provide a short and direct response. 0.92. What is the ratio of the Domestic credit (% of GDP) in Dominican Republic in 2006 to that in 2008?
Provide a succinct answer. 0.96. What is the ratio of the Domestic credit (% of GDP) in Moldova in 2006 to that in 2008?
Ensure brevity in your answer.  0.75. What is the ratio of the Domestic credit (% of GDP) of Antigua and Barbuda in 2007 to that in 2008?
Keep it short and to the point. 0.97. What is the ratio of the Domestic credit (% of GDP) of Dominican Republic in 2007 to that in 2008?
Keep it short and to the point. 1.01. What is the ratio of the Domestic credit (% of GDP) of Moldova in 2007 to that in 2008?
Give a very brief answer. 1.01. What is the difference between the highest and the second highest Domestic credit (% of GDP) of Antigua and Barbuda?
Your answer should be very brief. 2.04. What is the difference between the highest and the second highest Domestic credit (% of GDP) in Barbados?
Your answer should be compact. 5.42. What is the difference between the highest and the second highest Domestic credit (% of GDP) of Dominican Republic?
Keep it short and to the point. 11.64. What is the difference between the highest and the second highest Domestic credit (% of GDP) of Moldova?
Provide a succinct answer. 0.4. What is the difference between the highest and the lowest Domestic credit (% of GDP) in Antigua and Barbuda?
Make the answer very short. 5.96. What is the difference between the highest and the lowest Domestic credit (% of GDP) of Barbados?
Your response must be concise. 18.03. What is the difference between the highest and the lowest Domestic credit (% of GDP) of Dominican Republic?
Provide a short and direct response. 12.69. What is the difference between the highest and the lowest Domestic credit (% of GDP) in Moldova?
Provide a succinct answer. 16.55. 